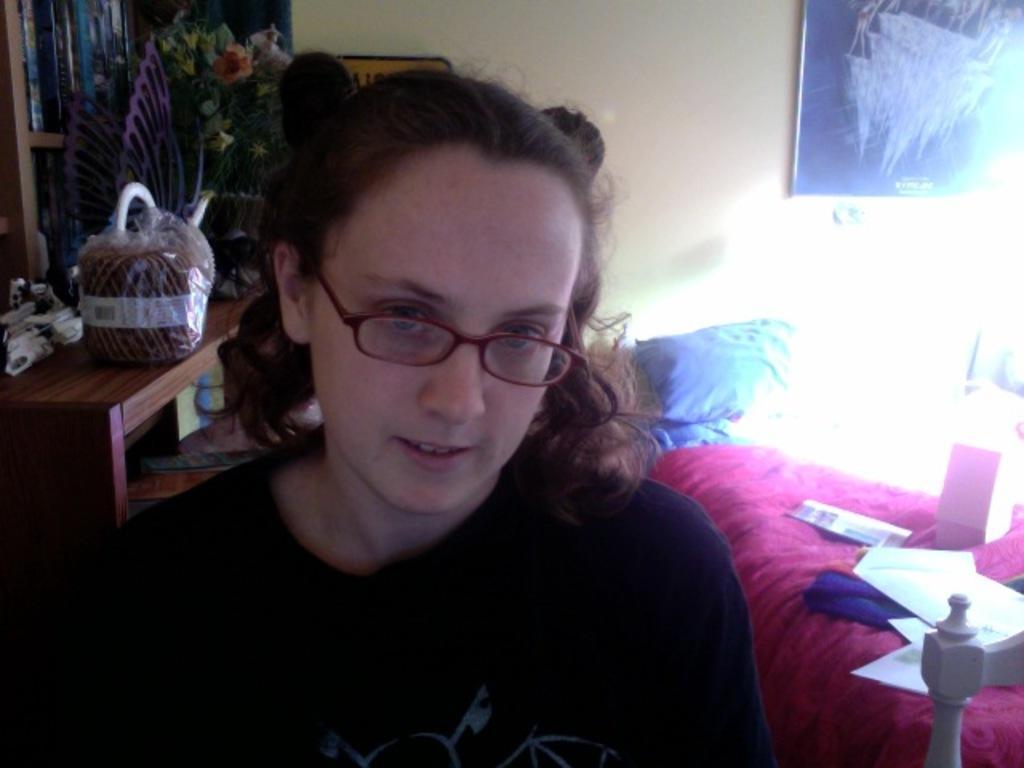Please provide a concise description of this image. In the image a woman is staring, behind her there is a bed and on the bed there is a pink color bed sheet,to the left side of the women there is a table, in the background there is a cream color wall and also a blue color poster on the wall. 